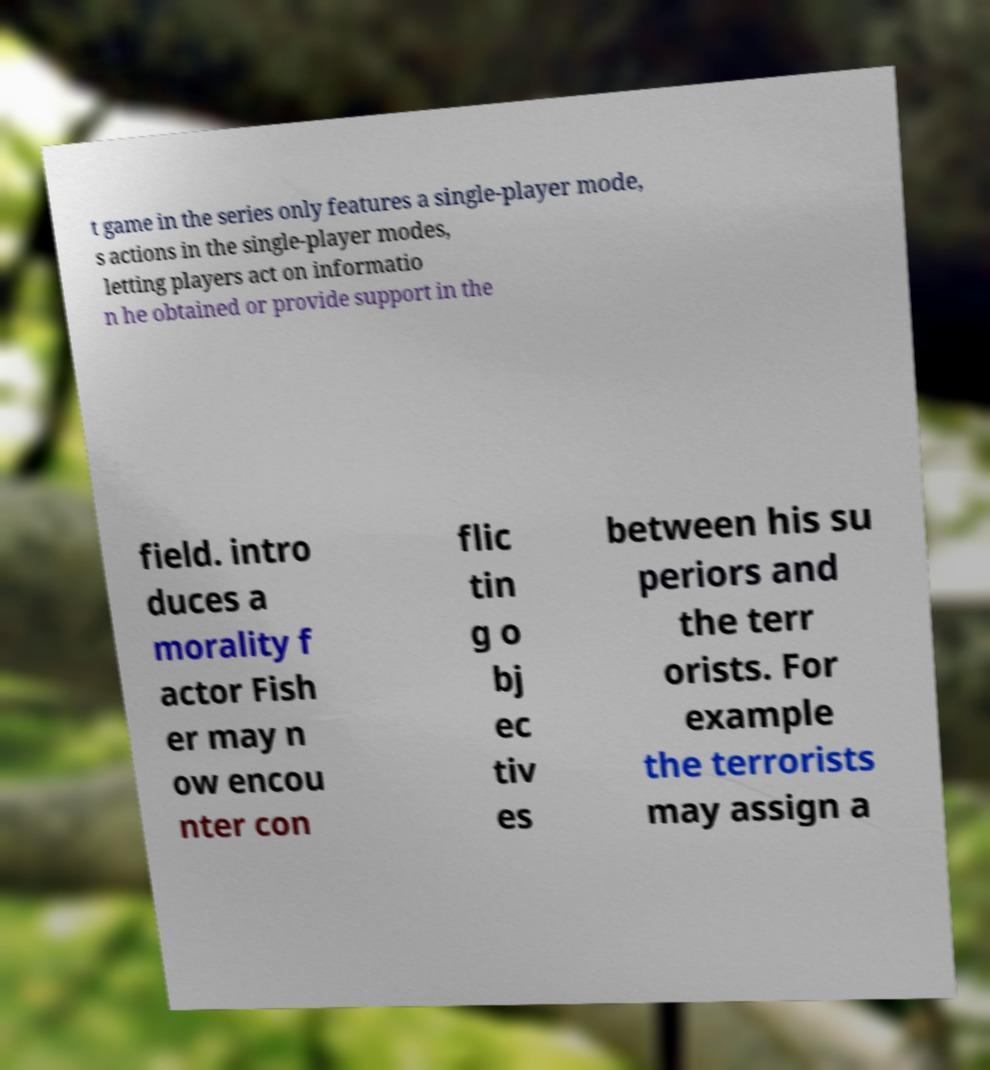Can you read and provide the text displayed in the image?This photo seems to have some interesting text. Can you extract and type it out for me? t game in the series only features a single-player mode, s actions in the single-player modes, letting players act on informatio n he obtained or provide support in the field. intro duces a morality f actor Fish er may n ow encou nter con flic tin g o bj ec tiv es between his su periors and the terr orists. For example the terrorists may assign a 